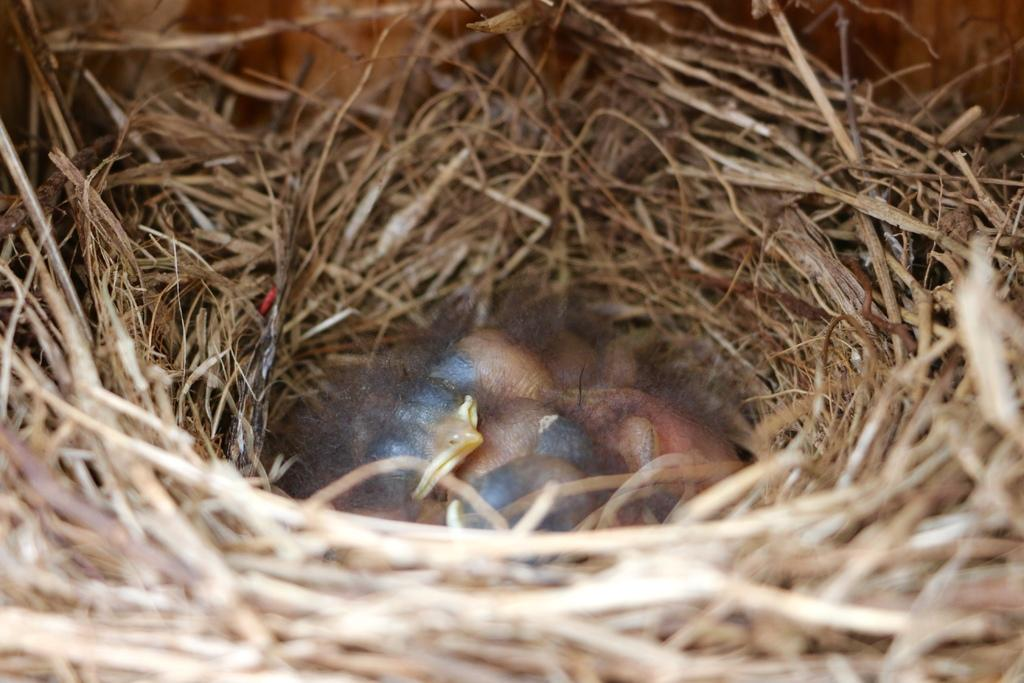What type of animals are present in the image? There are baby birds in the image. Where are the baby birds located? The baby birds are inside a nest. What is the color of the nest? The nest is brown in color. How many oranges are visible in the image? There are no oranges present in the image. What is the level of excitement of the baby birds during their birth? The image does not depict the birth of the baby birds, and therefore we cannot determine their level of excitement during that time. 